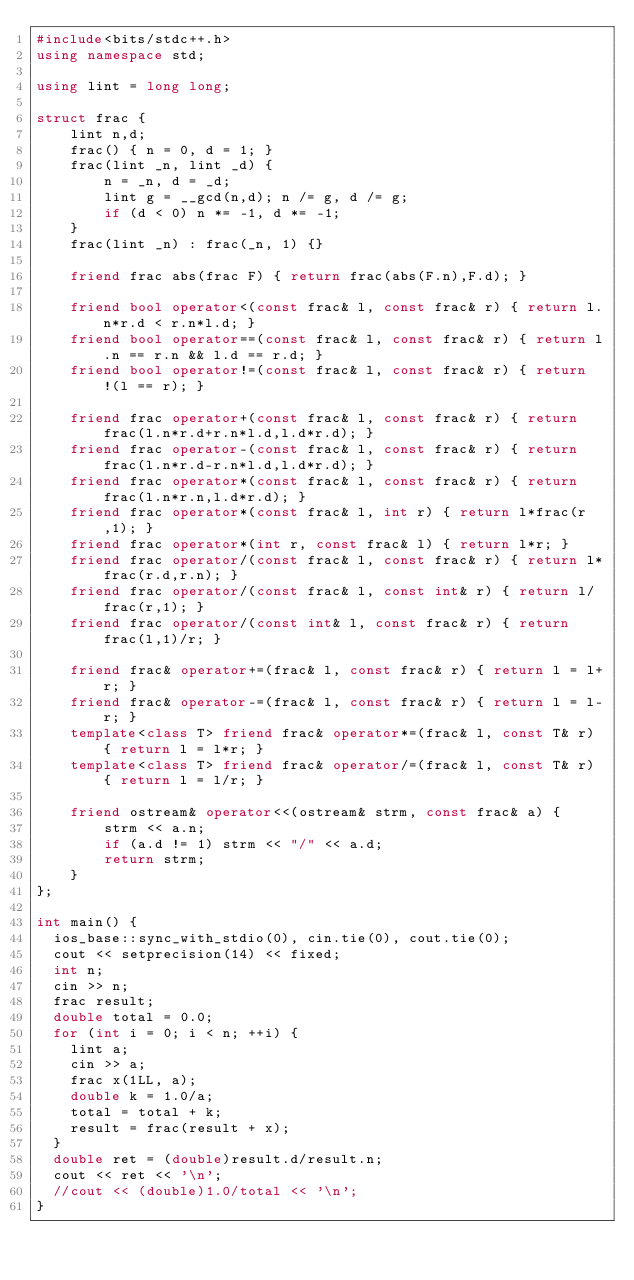Convert code to text. <code><loc_0><loc_0><loc_500><loc_500><_C++_>#include<bits/stdc++.h>
using namespace std;

using lint = long long;

struct frac {
    lint n,d;
    frac() { n = 0, d = 1; }
    frac(lint _n, lint _d) {
        n = _n, d = _d;
        lint g = __gcd(n,d); n /= g, d /= g;
        if (d < 0) n *= -1, d *= -1;
    }
    frac(lint _n) : frac(_n, 1) {}

    friend frac abs(frac F) { return frac(abs(F.n),F.d); }

    friend bool operator<(const frac& l, const frac& r) { return l.n*r.d < r.n*l.d; }
    friend bool operator==(const frac& l, const frac& r) { return l.n == r.n && l.d == r.d; }
    friend bool operator!=(const frac& l, const frac& r) { return !(l == r); }

    friend frac operator+(const frac& l, const frac& r) { return frac(l.n*r.d+r.n*l.d,l.d*r.d); }
    friend frac operator-(const frac& l, const frac& r) { return frac(l.n*r.d-r.n*l.d,l.d*r.d); }
    friend frac operator*(const frac& l, const frac& r) { return frac(l.n*r.n,l.d*r.d); }
    friend frac operator*(const frac& l, int r) { return l*frac(r,1); }
    friend frac operator*(int r, const frac& l) { return l*r; }
    friend frac operator/(const frac& l, const frac& r) { return l*frac(r.d,r.n); }
    friend frac operator/(const frac& l, const int& r) { return l/frac(r,1); }
    friend frac operator/(const int& l, const frac& r) { return frac(l,1)/r; }

    friend frac& operator+=(frac& l, const frac& r) { return l = l+r; }
    friend frac& operator-=(frac& l, const frac& r) { return l = l-r; }
    template<class T> friend frac& operator*=(frac& l, const T& r) { return l = l*r; }
    template<class T> friend frac& operator/=(frac& l, const T& r) { return l = l/r; }

    friend ostream& operator<<(ostream& strm, const frac& a) {
        strm << a.n;
        if (a.d != 1) strm << "/" << a.d;
        return strm;
    }
};

int main() {
	ios_base::sync_with_stdio(0), cin.tie(0), cout.tie(0);
	cout << setprecision(14) << fixed;
	int n;
	cin >> n;
	frac result;
	double total = 0.0;
	for (int i = 0; i < n; ++i) {
		lint a;
		cin >> a;
		frac x(1LL, a);
		double k = 1.0/a;
		total = total + k;
		result = frac(result + x);
	}
	double ret = (double)result.d/result.n;
	cout << ret << '\n';
	//cout << (double)1.0/total << '\n'; 
}

</code> 